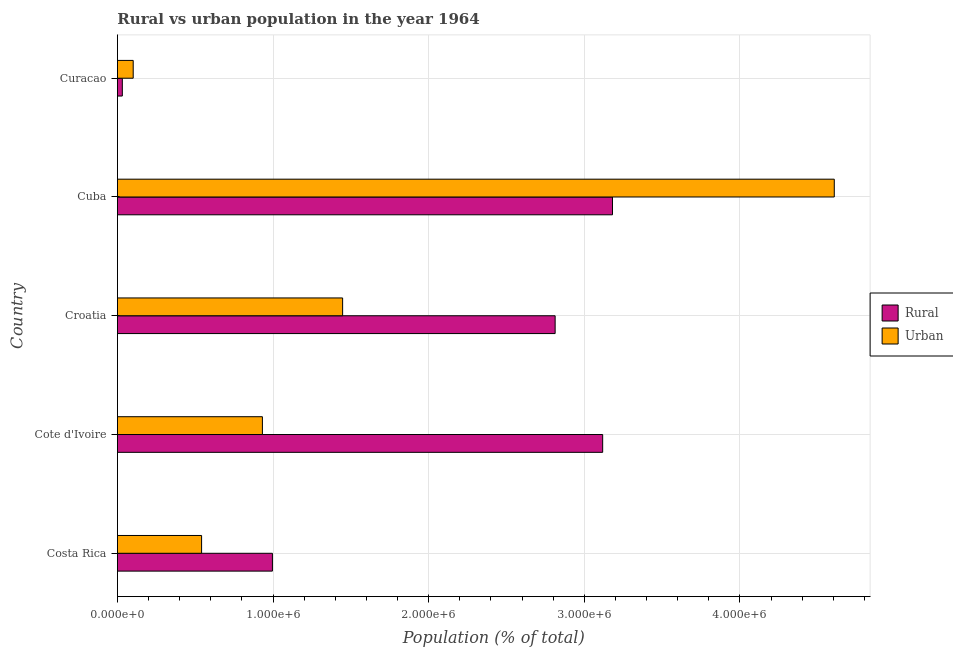How many bars are there on the 1st tick from the top?
Make the answer very short. 2. How many bars are there on the 2nd tick from the bottom?
Your answer should be compact. 2. What is the label of the 3rd group of bars from the top?
Your answer should be very brief. Croatia. What is the rural population density in Cote d'Ivoire?
Offer a terse response. 3.12e+06. Across all countries, what is the maximum urban population density?
Your answer should be compact. 4.61e+06. Across all countries, what is the minimum urban population density?
Make the answer very short. 1.02e+05. In which country was the rural population density maximum?
Ensure brevity in your answer.  Cuba. In which country was the urban population density minimum?
Your answer should be very brief. Curacao. What is the total rural population density in the graph?
Provide a short and direct response. 1.01e+07. What is the difference between the rural population density in Costa Rica and that in Cote d'Ivoire?
Ensure brevity in your answer.  -2.12e+06. What is the difference between the rural population density in Costa Rica and the urban population density in Cote d'Ivoire?
Provide a short and direct response. 6.43e+04. What is the average urban population density per country?
Provide a succinct answer. 1.53e+06. What is the difference between the urban population density and rural population density in Costa Rica?
Your answer should be very brief. -4.55e+05. What is the ratio of the urban population density in Cote d'Ivoire to that in Croatia?
Provide a short and direct response. 0.64. Is the urban population density in Croatia less than that in Cuba?
Offer a very short reply. Yes. Is the difference between the urban population density in Cuba and Curacao greater than the difference between the rural population density in Cuba and Curacao?
Give a very brief answer. Yes. What is the difference between the highest and the second highest rural population density?
Your answer should be very brief. 6.31e+04. What is the difference between the highest and the lowest urban population density?
Provide a succinct answer. 4.50e+06. Is the sum of the urban population density in Cote d'Ivoire and Curacao greater than the maximum rural population density across all countries?
Give a very brief answer. No. What does the 2nd bar from the top in Croatia represents?
Your answer should be compact. Rural. What does the 2nd bar from the bottom in Curacao represents?
Give a very brief answer. Urban. How many bars are there?
Provide a short and direct response. 10. How many countries are there in the graph?
Make the answer very short. 5. Are the values on the major ticks of X-axis written in scientific E-notation?
Provide a short and direct response. Yes. Does the graph contain any zero values?
Your answer should be compact. No. Does the graph contain grids?
Make the answer very short. Yes. How many legend labels are there?
Your response must be concise. 2. How are the legend labels stacked?
Give a very brief answer. Vertical. What is the title of the graph?
Provide a short and direct response. Rural vs urban population in the year 1964. What is the label or title of the X-axis?
Your answer should be very brief. Population (% of total). What is the Population (% of total) in Rural in Costa Rica?
Keep it short and to the point. 9.96e+05. What is the Population (% of total) of Urban in Costa Rica?
Your response must be concise. 5.41e+05. What is the Population (% of total) in Rural in Cote d'Ivoire?
Make the answer very short. 3.12e+06. What is the Population (% of total) of Urban in Cote d'Ivoire?
Provide a succinct answer. 9.32e+05. What is the Population (% of total) in Rural in Croatia?
Keep it short and to the point. 2.81e+06. What is the Population (% of total) in Urban in Croatia?
Your answer should be very brief. 1.45e+06. What is the Population (% of total) in Rural in Cuba?
Provide a short and direct response. 3.18e+06. What is the Population (% of total) of Urban in Cuba?
Make the answer very short. 4.61e+06. What is the Population (% of total) in Rural in Curacao?
Your answer should be compact. 3.16e+04. What is the Population (% of total) of Urban in Curacao?
Make the answer very short. 1.02e+05. Across all countries, what is the maximum Population (% of total) in Rural?
Ensure brevity in your answer.  3.18e+06. Across all countries, what is the maximum Population (% of total) in Urban?
Your response must be concise. 4.61e+06. Across all countries, what is the minimum Population (% of total) of Rural?
Your answer should be compact. 3.16e+04. Across all countries, what is the minimum Population (% of total) of Urban?
Make the answer very short. 1.02e+05. What is the total Population (% of total) of Rural in the graph?
Your answer should be very brief. 1.01e+07. What is the total Population (% of total) of Urban in the graph?
Provide a short and direct response. 7.63e+06. What is the difference between the Population (% of total) in Rural in Costa Rica and that in Cote d'Ivoire?
Make the answer very short. -2.12e+06. What is the difference between the Population (% of total) of Urban in Costa Rica and that in Cote d'Ivoire?
Your answer should be compact. -3.91e+05. What is the difference between the Population (% of total) of Rural in Costa Rica and that in Croatia?
Your answer should be compact. -1.82e+06. What is the difference between the Population (% of total) of Urban in Costa Rica and that in Croatia?
Your response must be concise. -9.06e+05. What is the difference between the Population (% of total) in Rural in Costa Rica and that in Cuba?
Make the answer very short. -2.19e+06. What is the difference between the Population (% of total) in Urban in Costa Rica and that in Cuba?
Provide a short and direct response. -4.07e+06. What is the difference between the Population (% of total) in Rural in Costa Rica and that in Curacao?
Your answer should be compact. 9.64e+05. What is the difference between the Population (% of total) in Urban in Costa Rica and that in Curacao?
Give a very brief answer. 4.39e+05. What is the difference between the Population (% of total) in Rural in Cote d'Ivoire and that in Croatia?
Keep it short and to the point. 3.05e+05. What is the difference between the Population (% of total) of Urban in Cote d'Ivoire and that in Croatia?
Ensure brevity in your answer.  -5.15e+05. What is the difference between the Population (% of total) of Rural in Cote d'Ivoire and that in Cuba?
Offer a very short reply. -6.31e+04. What is the difference between the Population (% of total) of Urban in Cote d'Ivoire and that in Cuba?
Provide a short and direct response. -3.67e+06. What is the difference between the Population (% of total) of Rural in Cote d'Ivoire and that in Curacao?
Offer a very short reply. 3.09e+06. What is the difference between the Population (% of total) of Urban in Cote d'Ivoire and that in Curacao?
Offer a terse response. 8.30e+05. What is the difference between the Population (% of total) of Rural in Croatia and that in Cuba?
Provide a succinct answer. -3.68e+05. What is the difference between the Population (% of total) of Urban in Croatia and that in Cuba?
Provide a succinct answer. -3.16e+06. What is the difference between the Population (% of total) in Rural in Croatia and that in Curacao?
Provide a succinct answer. 2.78e+06. What is the difference between the Population (% of total) in Urban in Croatia and that in Curacao?
Provide a succinct answer. 1.35e+06. What is the difference between the Population (% of total) of Rural in Cuba and that in Curacao?
Offer a terse response. 3.15e+06. What is the difference between the Population (% of total) in Urban in Cuba and that in Curacao?
Your response must be concise. 4.50e+06. What is the difference between the Population (% of total) of Rural in Costa Rica and the Population (% of total) of Urban in Cote d'Ivoire?
Provide a short and direct response. 6.43e+04. What is the difference between the Population (% of total) of Rural in Costa Rica and the Population (% of total) of Urban in Croatia?
Ensure brevity in your answer.  -4.51e+05. What is the difference between the Population (% of total) of Rural in Costa Rica and the Population (% of total) of Urban in Cuba?
Keep it short and to the point. -3.61e+06. What is the difference between the Population (% of total) in Rural in Costa Rica and the Population (% of total) in Urban in Curacao?
Offer a very short reply. 8.95e+05. What is the difference between the Population (% of total) in Rural in Cote d'Ivoire and the Population (% of total) in Urban in Croatia?
Give a very brief answer. 1.67e+06. What is the difference between the Population (% of total) of Rural in Cote d'Ivoire and the Population (% of total) of Urban in Cuba?
Your response must be concise. -1.49e+06. What is the difference between the Population (% of total) in Rural in Cote d'Ivoire and the Population (% of total) in Urban in Curacao?
Provide a succinct answer. 3.02e+06. What is the difference between the Population (% of total) in Rural in Croatia and the Population (% of total) in Urban in Cuba?
Your response must be concise. -1.79e+06. What is the difference between the Population (% of total) in Rural in Croatia and the Population (% of total) in Urban in Curacao?
Your answer should be very brief. 2.71e+06. What is the difference between the Population (% of total) of Rural in Cuba and the Population (% of total) of Urban in Curacao?
Provide a short and direct response. 3.08e+06. What is the average Population (% of total) in Rural per country?
Offer a terse response. 2.03e+06. What is the average Population (% of total) of Urban per country?
Make the answer very short. 1.53e+06. What is the difference between the Population (% of total) in Rural and Population (% of total) in Urban in Costa Rica?
Provide a short and direct response. 4.55e+05. What is the difference between the Population (% of total) of Rural and Population (% of total) of Urban in Cote d'Ivoire?
Your answer should be compact. 2.19e+06. What is the difference between the Population (% of total) of Rural and Population (% of total) of Urban in Croatia?
Offer a very short reply. 1.37e+06. What is the difference between the Population (% of total) in Rural and Population (% of total) in Urban in Cuba?
Ensure brevity in your answer.  -1.43e+06. What is the difference between the Population (% of total) of Rural and Population (% of total) of Urban in Curacao?
Make the answer very short. -6.99e+04. What is the ratio of the Population (% of total) in Rural in Costa Rica to that in Cote d'Ivoire?
Offer a terse response. 0.32. What is the ratio of the Population (% of total) in Urban in Costa Rica to that in Cote d'Ivoire?
Ensure brevity in your answer.  0.58. What is the ratio of the Population (% of total) in Rural in Costa Rica to that in Croatia?
Ensure brevity in your answer.  0.35. What is the ratio of the Population (% of total) in Urban in Costa Rica to that in Croatia?
Offer a very short reply. 0.37. What is the ratio of the Population (% of total) of Rural in Costa Rica to that in Cuba?
Your answer should be compact. 0.31. What is the ratio of the Population (% of total) in Urban in Costa Rica to that in Cuba?
Provide a short and direct response. 0.12. What is the ratio of the Population (% of total) in Rural in Costa Rica to that in Curacao?
Provide a succinct answer. 31.5. What is the ratio of the Population (% of total) in Urban in Costa Rica to that in Curacao?
Your answer should be very brief. 5.33. What is the ratio of the Population (% of total) in Rural in Cote d'Ivoire to that in Croatia?
Provide a succinct answer. 1.11. What is the ratio of the Population (% of total) in Urban in Cote d'Ivoire to that in Croatia?
Make the answer very short. 0.64. What is the ratio of the Population (% of total) of Rural in Cote d'Ivoire to that in Cuba?
Your answer should be compact. 0.98. What is the ratio of the Population (% of total) of Urban in Cote d'Ivoire to that in Cuba?
Provide a short and direct response. 0.2. What is the ratio of the Population (% of total) of Rural in Cote d'Ivoire to that in Curacao?
Make the answer very short. 98.62. What is the ratio of the Population (% of total) in Urban in Cote d'Ivoire to that in Curacao?
Ensure brevity in your answer.  9.18. What is the ratio of the Population (% of total) in Rural in Croatia to that in Cuba?
Make the answer very short. 0.88. What is the ratio of the Population (% of total) in Urban in Croatia to that in Cuba?
Your answer should be very brief. 0.31. What is the ratio of the Population (% of total) of Rural in Croatia to that in Curacao?
Ensure brevity in your answer.  88.96. What is the ratio of the Population (% of total) in Urban in Croatia to that in Curacao?
Provide a succinct answer. 14.25. What is the ratio of the Population (% of total) in Rural in Cuba to that in Curacao?
Provide a short and direct response. 100.62. What is the ratio of the Population (% of total) in Urban in Cuba to that in Curacao?
Your answer should be compact. 45.37. What is the difference between the highest and the second highest Population (% of total) of Rural?
Offer a very short reply. 6.31e+04. What is the difference between the highest and the second highest Population (% of total) of Urban?
Offer a very short reply. 3.16e+06. What is the difference between the highest and the lowest Population (% of total) of Rural?
Your answer should be very brief. 3.15e+06. What is the difference between the highest and the lowest Population (% of total) in Urban?
Provide a short and direct response. 4.50e+06. 